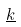<formula> <loc_0><loc_0><loc_500><loc_500>\underline { k }</formula> 